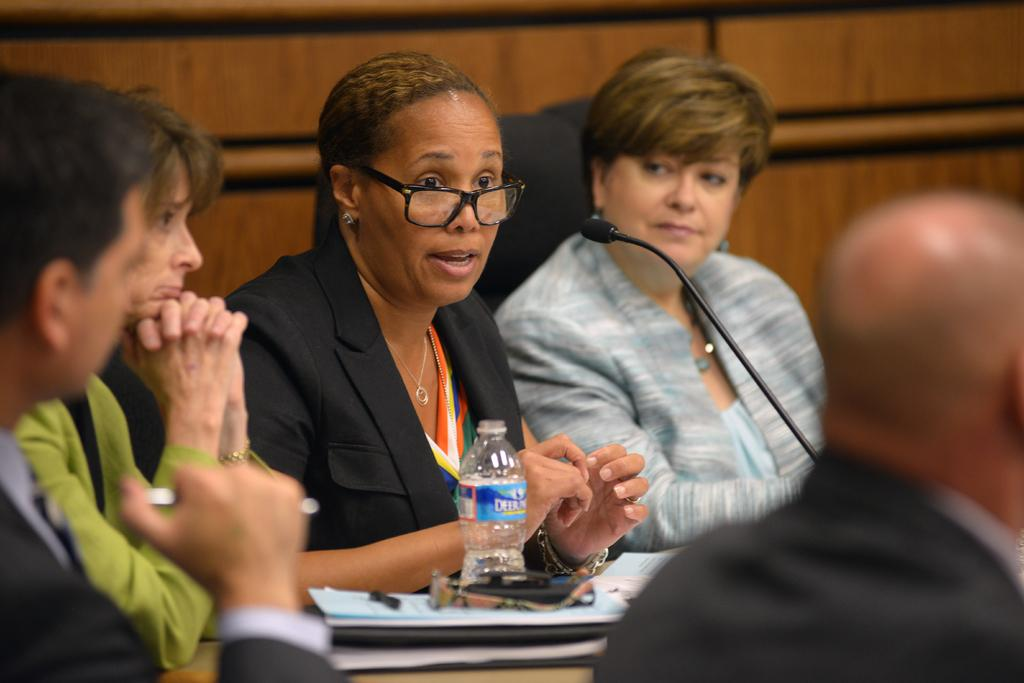Who or what is present in the image? There are people in the image. What object can be seen near the people? There is a microphone in the image. What else can be seen in the image besides the people and the microphone? There are objects on a table in the image. How many boats are visible in the image? There are no boats present in the image. What achievement did the person in the image receive? The image does not provide information about any achievements or awards. 